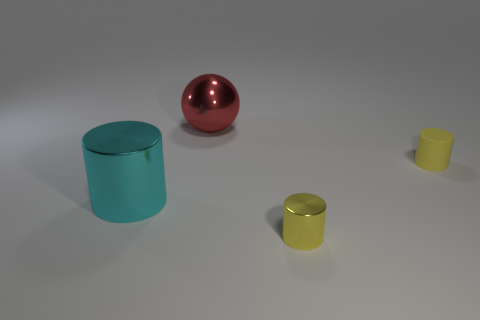Is the shape of the matte thing the same as the large object behind the large metallic cylinder?
Your answer should be compact. No. There is a yellow thing on the left side of the rubber cylinder; is it the same size as the large cyan cylinder?
Your answer should be very brief. No. There is a yellow metal object that is the same size as the matte object; what is its shape?
Offer a terse response. Cylinder. Does the small matte thing have the same shape as the tiny yellow shiny thing?
Your response must be concise. Yes. How many other matte things are the same shape as the cyan thing?
Your response must be concise. 1. What number of small yellow cylinders are behind the big metallic cylinder?
Your response must be concise. 1. Is the color of the small cylinder in front of the small matte cylinder the same as the ball?
Ensure brevity in your answer.  No. How many cyan metal cylinders are the same size as the yellow rubber thing?
Your answer should be compact. 0. There is a big thing that is the same material as the cyan cylinder; what shape is it?
Give a very brief answer. Sphere. Are there any large objects that have the same color as the large cylinder?
Your response must be concise. No. 